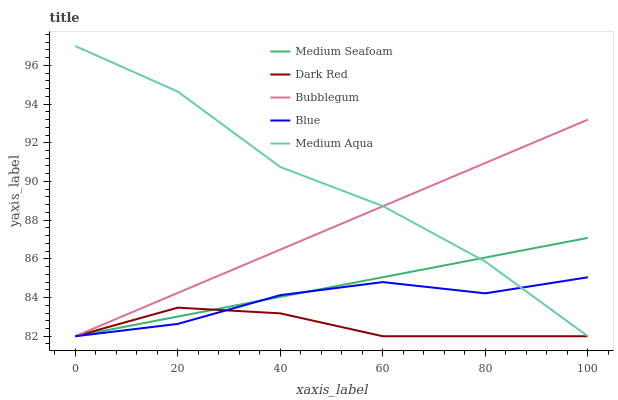Does Medium Aqua have the minimum area under the curve?
Answer yes or no. No. Does Dark Red have the maximum area under the curve?
Answer yes or no. No. Is Dark Red the smoothest?
Answer yes or no. No. Is Dark Red the roughest?
Answer yes or no. No. Does Dark Red have the highest value?
Answer yes or no. No. 